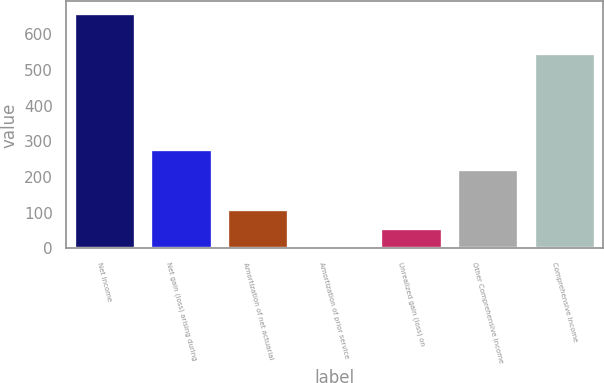<chart> <loc_0><loc_0><loc_500><loc_500><bar_chart><fcel>Net Income<fcel>Net gain (loss) arising during<fcel>Amortization of net actuarial<fcel>Amortization of prior service<fcel>Unrealized gain (loss) on<fcel>Other Comprehensive Income<fcel>Comprehensive Income<nl><fcel>658.4<fcel>277<fcel>111.4<fcel>1<fcel>56.2<fcel>221.8<fcel>548<nl></chart> 